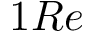Convert formula to latex. <formula><loc_0><loc_0><loc_500><loc_500>1 R e</formula> 